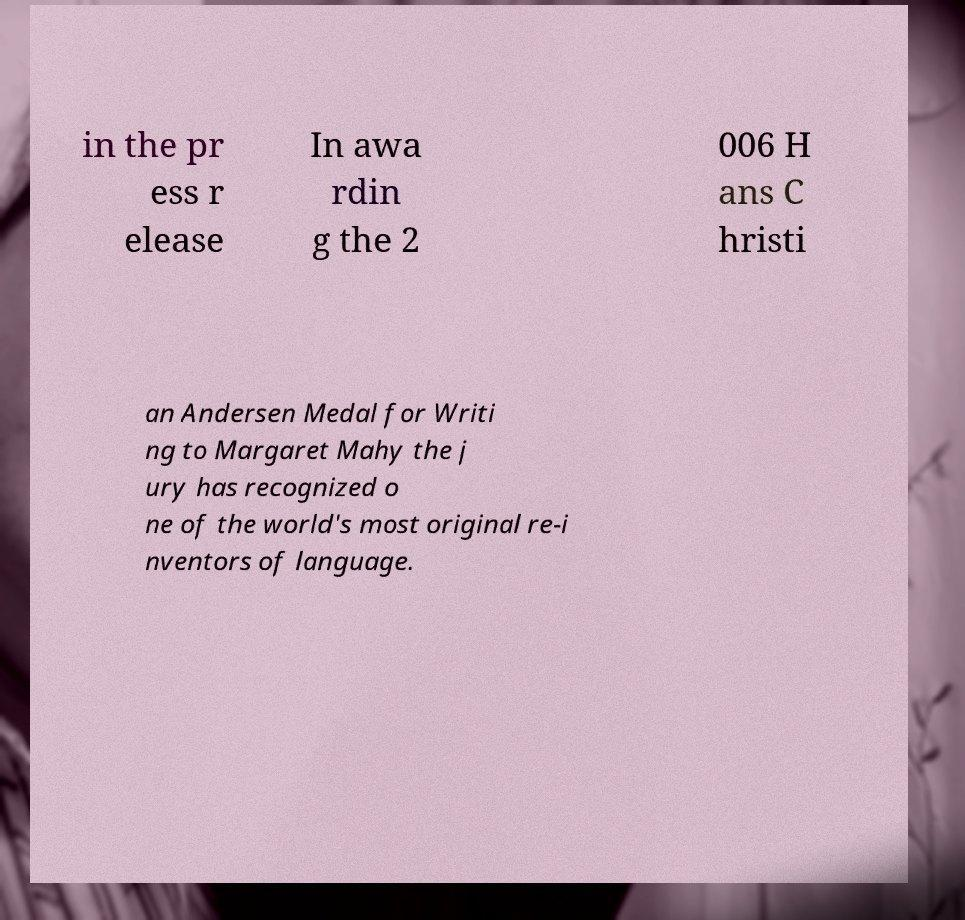Could you extract and type out the text from this image? in the pr ess r elease In awa rdin g the 2 006 H ans C hristi an Andersen Medal for Writi ng to Margaret Mahy the j ury has recognized o ne of the world's most original re-i nventors of language. 